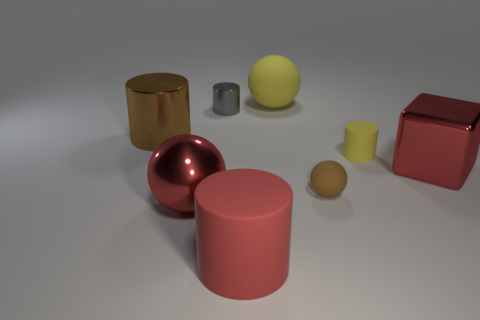How many matte things are either red cylinders or big blue things?
Provide a succinct answer. 1. Are there any brown spheres?
Offer a very short reply. Yes. Does the red rubber object have the same shape as the small yellow rubber object?
Make the answer very short. Yes. How many big balls are behind the cylinder in front of the small rubber thing behind the large red block?
Provide a succinct answer. 2. What is the sphere that is both right of the large red sphere and to the left of the tiny brown ball made of?
Offer a very short reply. Rubber. The big thing that is both in front of the block and behind the big rubber cylinder is what color?
Your answer should be very brief. Red. Is there any other thing that has the same color as the tiny metallic object?
Offer a very short reply. No. What shape is the metallic thing in front of the red thing behind the big red metal thing to the left of the yellow matte sphere?
Provide a succinct answer. Sphere. What is the color of the big metallic object that is the same shape as the tiny gray metal thing?
Give a very brief answer. Brown. There is a metal cylinder that is right of the large red shiny thing in front of the tiny brown object; what is its color?
Provide a short and direct response. Gray. 